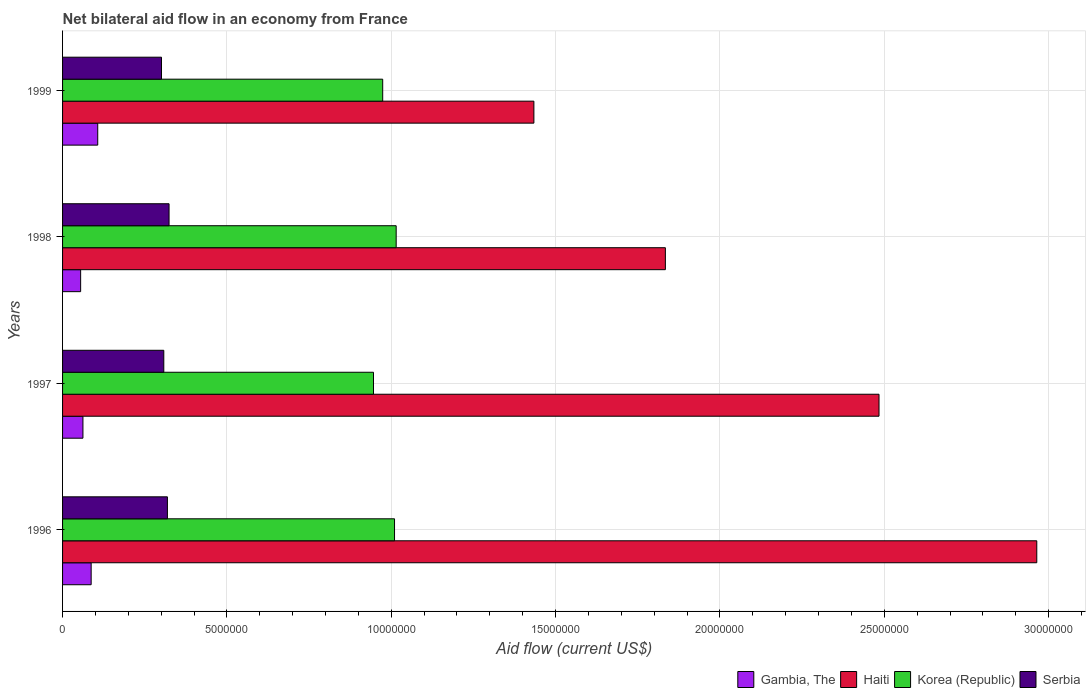Are the number of bars on each tick of the Y-axis equal?
Your response must be concise. Yes. How many bars are there on the 3rd tick from the top?
Your answer should be very brief. 4. What is the net bilateral aid flow in Gambia, The in 1997?
Your answer should be very brief. 6.20e+05. Across all years, what is the maximum net bilateral aid flow in Korea (Republic)?
Ensure brevity in your answer.  1.02e+07. Across all years, what is the minimum net bilateral aid flow in Serbia?
Keep it short and to the point. 3.01e+06. In which year was the net bilateral aid flow in Korea (Republic) maximum?
Offer a very short reply. 1998. In which year was the net bilateral aid flow in Korea (Republic) minimum?
Make the answer very short. 1997. What is the total net bilateral aid flow in Serbia in the graph?
Provide a short and direct response. 1.25e+07. What is the difference between the net bilateral aid flow in Haiti in 1997 and that in 1999?
Offer a terse response. 1.05e+07. What is the difference between the net bilateral aid flow in Haiti in 1998 and the net bilateral aid flow in Korea (Republic) in 1997?
Offer a very short reply. 8.88e+06. What is the average net bilateral aid flow in Gambia, The per year?
Your answer should be very brief. 7.78e+05. In the year 1997, what is the difference between the net bilateral aid flow in Serbia and net bilateral aid flow in Haiti?
Give a very brief answer. -2.18e+07. What is the ratio of the net bilateral aid flow in Haiti in 1996 to that in 1999?
Provide a short and direct response. 2.07. Is the net bilateral aid flow in Gambia, The in 1996 less than that in 1998?
Provide a short and direct response. No. What is the difference between the highest and the second highest net bilateral aid flow in Korea (Republic)?
Keep it short and to the point. 5.00e+04. What is the difference between the highest and the lowest net bilateral aid flow in Korea (Republic)?
Offer a very short reply. 6.90e+05. Is the sum of the net bilateral aid flow in Haiti in 1996 and 1997 greater than the maximum net bilateral aid flow in Gambia, The across all years?
Your response must be concise. Yes. Is it the case that in every year, the sum of the net bilateral aid flow in Serbia and net bilateral aid flow in Haiti is greater than the sum of net bilateral aid flow in Gambia, The and net bilateral aid flow in Korea (Republic)?
Give a very brief answer. No. What does the 1st bar from the top in 1997 represents?
Your answer should be compact. Serbia. What does the 4th bar from the bottom in 1996 represents?
Make the answer very short. Serbia. Is it the case that in every year, the sum of the net bilateral aid flow in Haiti and net bilateral aid flow in Serbia is greater than the net bilateral aid flow in Korea (Republic)?
Provide a short and direct response. Yes. How many bars are there?
Provide a succinct answer. 16. What is the difference between two consecutive major ticks on the X-axis?
Your response must be concise. 5.00e+06. Does the graph contain grids?
Provide a succinct answer. Yes. How are the legend labels stacked?
Your answer should be very brief. Horizontal. What is the title of the graph?
Offer a very short reply. Net bilateral aid flow in an economy from France. Does "Chile" appear as one of the legend labels in the graph?
Give a very brief answer. No. What is the label or title of the X-axis?
Offer a terse response. Aid flow (current US$). What is the Aid flow (current US$) in Gambia, The in 1996?
Your answer should be very brief. 8.70e+05. What is the Aid flow (current US$) in Haiti in 1996?
Make the answer very short. 2.96e+07. What is the Aid flow (current US$) in Korea (Republic) in 1996?
Give a very brief answer. 1.01e+07. What is the Aid flow (current US$) of Serbia in 1996?
Offer a terse response. 3.19e+06. What is the Aid flow (current US$) in Gambia, The in 1997?
Give a very brief answer. 6.20e+05. What is the Aid flow (current US$) of Haiti in 1997?
Offer a very short reply. 2.48e+07. What is the Aid flow (current US$) in Korea (Republic) in 1997?
Your answer should be compact. 9.46e+06. What is the Aid flow (current US$) of Serbia in 1997?
Ensure brevity in your answer.  3.08e+06. What is the Aid flow (current US$) in Haiti in 1998?
Provide a short and direct response. 1.83e+07. What is the Aid flow (current US$) of Korea (Republic) in 1998?
Ensure brevity in your answer.  1.02e+07. What is the Aid flow (current US$) of Serbia in 1998?
Offer a very short reply. 3.24e+06. What is the Aid flow (current US$) of Gambia, The in 1999?
Your response must be concise. 1.07e+06. What is the Aid flow (current US$) of Haiti in 1999?
Your answer should be very brief. 1.43e+07. What is the Aid flow (current US$) in Korea (Republic) in 1999?
Provide a succinct answer. 9.74e+06. What is the Aid flow (current US$) of Serbia in 1999?
Keep it short and to the point. 3.01e+06. Across all years, what is the maximum Aid flow (current US$) in Gambia, The?
Offer a very short reply. 1.07e+06. Across all years, what is the maximum Aid flow (current US$) in Haiti?
Make the answer very short. 2.96e+07. Across all years, what is the maximum Aid flow (current US$) in Korea (Republic)?
Your response must be concise. 1.02e+07. Across all years, what is the maximum Aid flow (current US$) of Serbia?
Your response must be concise. 3.24e+06. Across all years, what is the minimum Aid flow (current US$) of Gambia, The?
Your response must be concise. 5.50e+05. Across all years, what is the minimum Aid flow (current US$) in Haiti?
Keep it short and to the point. 1.43e+07. Across all years, what is the minimum Aid flow (current US$) of Korea (Republic)?
Provide a short and direct response. 9.46e+06. Across all years, what is the minimum Aid flow (current US$) of Serbia?
Make the answer very short. 3.01e+06. What is the total Aid flow (current US$) of Gambia, The in the graph?
Provide a short and direct response. 3.11e+06. What is the total Aid flow (current US$) in Haiti in the graph?
Keep it short and to the point. 8.72e+07. What is the total Aid flow (current US$) in Korea (Republic) in the graph?
Make the answer very short. 3.94e+07. What is the total Aid flow (current US$) of Serbia in the graph?
Your answer should be very brief. 1.25e+07. What is the difference between the Aid flow (current US$) of Haiti in 1996 and that in 1997?
Provide a succinct answer. 4.80e+06. What is the difference between the Aid flow (current US$) of Korea (Republic) in 1996 and that in 1997?
Your answer should be compact. 6.40e+05. What is the difference between the Aid flow (current US$) in Haiti in 1996 and that in 1998?
Make the answer very short. 1.13e+07. What is the difference between the Aid flow (current US$) of Serbia in 1996 and that in 1998?
Ensure brevity in your answer.  -5.00e+04. What is the difference between the Aid flow (current US$) of Haiti in 1996 and that in 1999?
Make the answer very short. 1.53e+07. What is the difference between the Aid flow (current US$) in Serbia in 1996 and that in 1999?
Your response must be concise. 1.80e+05. What is the difference between the Aid flow (current US$) in Gambia, The in 1997 and that in 1998?
Your response must be concise. 7.00e+04. What is the difference between the Aid flow (current US$) of Haiti in 1997 and that in 1998?
Make the answer very short. 6.50e+06. What is the difference between the Aid flow (current US$) in Korea (Republic) in 1997 and that in 1998?
Your response must be concise. -6.90e+05. What is the difference between the Aid flow (current US$) of Gambia, The in 1997 and that in 1999?
Your response must be concise. -4.50e+05. What is the difference between the Aid flow (current US$) of Haiti in 1997 and that in 1999?
Your answer should be very brief. 1.05e+07. What is the difference between the Aid flow (current US$) of Korea (Republic) in 1997 and that in 1999?
Your answer should be compact. -2.80e+05. What is the difference between the Aid flow (current US$) of Gambia, The in 1998 and that in 1999?
Your response must be concise. -5.20e+05. What is the difference between the Aid flow (current US$) of Haiti in 1998 and that in 1999?
Your answer should be compact. 4.00e+06. What is the difference between the Aid flow (current US$) of Korea (Republic) in 1998 and that in 1999?
Provide a succinct answer. 4.10e+05. What is the difference between the Aid flow (current US$) of Serbia in 1998 and that in 1999?
Offer a very short reply. 2.30e+05. What is the difference between the Aid flow (current US$) in Gambia, The in 1996 and the Aid flow (current US$) in Haiti in 1997?
Keep it short and to the point. -2.40e+07. What is the difference between the Aid flow (current US$) in Gambia, The in 1996 and the Aid flow (current US$) in Korea (Republic) in 1997?
Ensure brevity in your answer.  -8.59e+06. What is the difference between the Aid flow (current US$) of Gambia, The in 1996 and the Aid flow (current US$) of Serbia in 1997?
Your response must be concise. -2.21e+06. What is the difference between the Aid flow (current US$) in Haiti in 1996 and the Aid flow (current US$) in Korea (Republic) in 1997?
Your response must be concise. 2.02e+07. What is the difference between the Aid flow (current US$) in Haiti in 1996 and the Aid flow (current US$) in Serbia in 1997?
Ensure brevity in your answer.  2.66e+07. What is the difference between the Aid flow (current US$) in Korea (Republic) in 1996 and the Aid flow (current US$) in Serbia in 1997?
Ensure brevity in your answer.  7.02e+06. What is the difference between the Aid flow (current US$) in Gambia, The in 1996 and the Aid flow (current US$) in Haiti in 1998?
Give a very brief answer. -1.75e+07. What is the difference between the Aid flow (current US$) of Gambia, The in 1996 and the Aid flow (current US$) of Korea (Republic) in 1998?
Your answer should be very brief. -9.28e+06. What is the difference between the Aid flow (current US$) in Gambia, The in 1996 and the Aid flow (current US$) in Serbia in 1998?
Give a very brief answer. -2.37e+06. What is the difference between the Aid flow (current US$) of Haiti in 1996 and the Aid flow (current US$) of Korea (Republic) in 1998?
Your response must be concise. 1.95e+07. What is the difference between the Aid flow (current US$) of Haiti in 1996 and the Aid flow (current US$) of Serbia in 1998?
Provide a short and direct response. 2.64e+07. What is the difference between the Aid flow (current US$) in Korea (Republic) in 1996 and the Aid flow (current US$) in Serbia in 1998?
Your response must be concise. 6.86e+06. What is the difference between the Aid flow (current US$) of Gambia, The in 1996 and the Aid flow (current US$) of Haiti in 1999?
Provide a succinct answer. -1.35e+07. What is the difference between the Aid flow (current US$) in Gambia, The in 1996 and the Aid flow (current US$) in Korea (Republic) in 1999?
Provide a succinct answer. -8.87e+06. What is the difference between the Aid flow (current US$) of Gambia, The in 1996 and the Aid flow (current US$) of Serbia in 1999?
Make the answer very short. -2.14e+06. What is the difference between the Aid flow (current US$) in Haiti in 1996 and the Aid flow (current US$) in Korea (Republic) in 1999?
Make the answer very short. 1.99e+07. What is the difference between the Aid flow (current US$) in Haiti in 1996 and the Aid flow (current US$) in Serbia in 1999?
Offer a terse response. 2.66e+07. What is the difference between the Aid flow (current US$) in Korea (Republic) in 1996 and the Aid flow (current US$) in Serbia in 1999?
Offer a very short reply. 7.09e+06. What is the difference between the Aid flow (current US$) of Gambia, The in 1997 and the Aid flow (current US$) of Haiti in 1998?
Your answer should be compact. -1.77e+07. What is the difference between the Aid flow (current US$) in Gambia, The in 1997 and the Aid flow (current US$) in Korea (Republic) in 1998?
Offer a very short reply. -9.53e+06. What is the difference between the Aid flow (current US$) in Gambia, The in 1997 and the Aid flow (current US$) in Serbia in 1998?
Provide a succinct answer. -2.62e+06. What is the difference between the Aid flow (current US$) of Haiti in 1997 and the Aid flow (current US$) of Korea (Republic) in 1998?
Your answer should be compact. 1.47e+07. What is the difference between the Aid flow (current US$) of Haiti in 1997 and the Aid flow (current US$) of Serbia in 1998?
Your response must be concise. 2.16e+07. What is the difference between the Aid flow (current US$) of Korea (Republic) in 1997 and the Aid flow (current US$) of Serbia in 1998?
Give a very brief answer. 6.22e+06. What is the difference between the Aid flow (current US$) of Gambia, The in 1997 and the Aid flow (current US$) of Haiti in 1999?
Your answer should be very brief. -1.37e+07. What is the difference between the Aid flow (current US$) in Gambia, The in 1997 and the Aid flow (current US$) in Korea (Republic) in 1999?
Make the answer very short. -9.12e+06. What is the difference between the Aid flow (current US$) of Gambia, The in 1997 and the Aid flow (current US$) of Serbia in 1999?
Your response must be concise. -2.39e+06. What is the difference between the Aid flow (current US$) in Haiti in 1997 and the Aid flow (current US$) in Korea (Republic) in 1999?
Keep it short and to the point. 1.51e+07. What is the difference between the Aid flow (current US$) in Haiti in 1997 and the Aid flow (current US$) in Serbia in 1999?
Provide a short and direct response. 2.18e+07. What is the difference between the Aid flow (current US$) of Korea (Republic) in 1997 and the Aid flow (current US$) of Serbia in 1999?
Offer a very short reply. 6.45e+06. What is the difference between the Aid flow (current US$) of Gambia, The in 1998 and the Aid flow (current US$) of Haiti in 1999?
Offer a very short reply. -1.38e+07. What is the difference between the Aid flow (current US$) in Gambia, The in 1998 and the Aid flow (current US$) in Korea (Republic) in 1999?
Give a very brief answer. -9.19e+06. What is the difference between the Aid flow (current US$) in Gambia, The in 1998 and the Aid flow (current US$) in Serbia in 1999?
Your answer should be compact. -2.46e+06. What is the difference between the Aid flow (current US$) in Haiti in 1998 and the Aid flow (current US$) in Korea (Republic) in 1999?
Provide a short and direct response. 8.60e+06. What is the difference between the Aid flow (current US$) of Haiti in 1998 and the Aid flow (current US$) of Serbia in 1999?
Provide a succinct answer. 1.53e+07. What is the difference between the Aid flow (current US$) in Korea (Republic) in 1998 and the Aid flow (current US$) in Serbia in 1999?
Provide a short and direct response. 7.14e+06. What is the average Aid flow (current US$) of Gambia, The per year?
Offer a very short reply. 7.78e+05. What is the average Aid flow (current US$) of Haiti per year?
Offer a terse response. 2.18e+07. What is the average Aid flow (current US$) of Korea (Republic) per year?
Your answer should be compact. 9.86e+06. What is the average Aid flow (current US$) of Serbia per year?
Provide a short and direct response. 3.13e+06. In the year 1996, what is the difference between the Aid flow (current US$) of Gambia, The and Aid flow (current US$) of Haiti?
Provide a succinct answer. -2.88e+07. In the year 1996, what is the difference between the Aid flow (current US$) in Gambia, The and Aid flow (current US$) in Korea (Republic)?
Make the answer very short. -9.23e+06. In the year 1996, what is the difference between the Aid flow (current US$) of Gambia, The and Aid flow (current US$) of Serbia?
Keep it short and to the point. -2.32e+06. In the year 1996, what is the difference between the Aid flow (current US$) in Haiti and Aid flow (current US$) in Korea (Republic)?
Provide a short and direct response. 1.95e+07. In the year 1996, what is the difference between the Aid flow (current US$) in Haiti and Aid flow (current US$) in Serbia?
Offer a terse response. 2.64e+07. In the year 1996, what is the difference between the Aid flow (current US$) in Korea (Republic) and Aid flow (current US$) in Serbia?
Your answer should be compact. 6.91e+06. In the year 1997, what is the difference between the Aid flow (current US$) of Gambia, The and Aid flow (current US$) of Haiti?
Provide a succinct answer. -2.42e+07. In the year 1997, what is the difference between the Aid flow (current US$) in Gambia, The and Aid flow (current US$) in Korea (Republic)?
Your response must be concise. -8.84e+06. In the year 1997, what is the difference between the Aid flow (current US$) of Gambia, The and Aid flow (current US$) of Serbia?
Provide a succinct answer. -2.46e+06. In the year 1997, what is the difference between the Aid flow (current US$) of Haiti and Aid flow (current US$) of Korea (Republic)?
Offer a terse response. 1.54e+07. In the year 1997, what is the difference between the Aid flow (current US$) of Haiti and Aid flow (current US$) of Serbia?
Provide a succinct answer. 2.18e+07. In the year 1997, what is the difference between the Aid flow (current US$) in Korea (Republic) and Aid flow (current US$) in Serbia?
Your response must be concise. 6.38e+06. In the year 1998, what is the difference between the Aid flow (current US$) in Gambia, The and Aid flow (current US$) in Haiti?
Keep it short and to the point. -1.78e+07. In the year 1998, what is the difference between the Aid flow (current US$) of Gambia, The and Aid flow (current US$) of Korea (Republic)?
Give a very brief answer. -9.60e+06. In the year 1998, what is the difference between the Aid flow (current US$) in Gambia, The and Aid flow (current US$) in Serbia?
Keep it short and to the point. -2.69e+06. In the year 1998, what is the difference between the Aid flow (current US$) of Haiti and Aid flow (current US$) of Korea (Republic)?
Keep it short and to the point. 8.19e+06. In the year 1998, what is the difference between the Aid flow (current US$) in Haiti and Aid flow (current US$) in Serbia?
Make the answer very short. 1.51e+07. In the year 1998, what is the difference between the Aid flow (current US$) of Korea (Republic) and Aid flow (current US$) of Serbia?
Give a very brief answer. 6.91e+06. In the year 1999, what is the difference between the Aid flow (current US$) of Gambia, The and Aid flow (current US$) of Haiti?
Your response must be concise. -1.33e+07. In the year 1999, what is the difference between the Aid flow (current US$) in Gambia, The and Aid flow (current US$) in Korea (Republic)?
Offer a very short reply. -8.67e+06. In the year 1999, what is the difference between the Aid flow (current US$) in Gambia, The and Aid flow (current US$) in Serbia?
Offer a terse response. -1.94e+06. In the year 1999, what is the difference between the Aid flow (current US$) in Haiti and Aid flow (current US$) in Korea (Republic)?
Your answer should be very brief. 4.60e+06. In the year 1999, what is the difference between the Aid flow (current US$) of Haiti and Aid flow (current US$) of Serbia?
Offer a terse response. 1.13e+07. In the year 1999, what is the difference between the Aid flow (current US$) of Korea (Republic) and Aid flow (current US$) of Serbia?
Offer a terse response. 6.73e+06. What is the ratio of the Aid flow (current US$) in Gambia, The in 1996 to that in 1997?
Make the answer very short. 1.4. What is the ratio of the Aid flow (current US$) of Haiti in 1996 to that in 1997?
Give a very brief answer. 1.19. What is the ratio of the Aid flow (current US$) of Korea (Republic) in 1996 to that in 1997?
Your response must be concise. 1.07. What is the ratio of the Aid flow (current US$) in Serbia in 1996 to that in 1997?
Offer a terse response. 1.04. What is the ratio of the Aid flow (current US$) in Gambia, The in 1996 to that in 1998?
Your answer should be compact. 1.58. What is the ratio of the Aid flow (current US$) in Haiti in 1996 to that in 1998?
Your answer should be compact. 1.62. What is the ratio of the Aid flow (current US$) in Serbia in 1996 to that in 1998?
Make the answer very short. 0.98. What is the ratio of the Aid flow (current US$) of Gambia, The in 1996 to that in 1999?
Provide a short and direct response. 0.81. What is the ratio of the Aid flow (current US$) in Haiti in 1996 to that in 1999?
Make the answer very short. 2.07. What is the ratio of the Aid flow (current US$) in Korea (Republic) in 1996 to that in 1999?
Make the answer very short. 1.04. What is the ratio of the Aid flow (current US$) of Serbia in 1996 to that in 1999?
Ensure brevity in your answer.  1.06. What is the ratio of the Aid flow (current US$) of Gambia, The in 1997 to that in 1998?
Your answer should be compact. 1.13. What is the ratio of the Aid flow (current US$) of Haiti in 1997 to that in 1998?
Offer a very short reply. 1.35. What is the ratio of the Aid flow (current US$) of Korea (Republic) in 1997 to that in 1998?
Offer a terse response. 0.93. What is the ratio of the Aid flow (current US$) in Serbia in 1997 to that in 1998?
Your response must be concise. 0.95. What is the ratio of the Aid flow (current US$) in Gambia, The in 1997 to that in 1999?
Your answer should be very brief. 0.58. What is the ratio of the Aid flow (current US$) in Haiti in 1997 to that in 1999?
Your answer should be compact. 1.73. What is the ratio of the Aid flow (current US$) of Korea (Republic) in 1997 to that in 1999?
Your answer should be very brief. 0.97. What is the ratio of the Aid flow (current US$) of Serbia in 1997 to that in 1999?
Your answer should be very brief. 1.02. What is the ratio of the Aid flow (current US$) of Gambia, The in 1998 to that in 1999?
Provide a short and direct response. 0.51. What is the ratio of the Aid flow (current US$) of Haiti in 1998 to that in 1999?
Your response must be concise. 1.28. What is the ratio of the Aid flow (current US$) in Korea (Republic) in 1998 to that in 1999?
Make the answer very short. 1.04. What is the ratio of the Aid flow (current US$) in Serbia in 1998 to that in 1999?
Provide a succinct answer. 1.08. What is the difference between the highest and the second highest Aid flow (current US$) of Haiti?
Your response must be concise. 4.80e+06. What is the difference between the highest and the second highest Aid flow (current US$) of Korea (Republic)?
Provide a succinct answer. 5.00e+04. What is the difference between the highest and the lowest Aid flow (current US$) in Gambia, The?
Your response must be concise. 5.20e+05. What is the difference between the highest and the lowest Aid flow (current US$) in Haiti?
Keep it short and to the point. 1.53e+07. What is the difference between the highest and the lowest Aid flow (current US$) in Korea (Republic)?
Offer a terse response. 6.90e+05. 